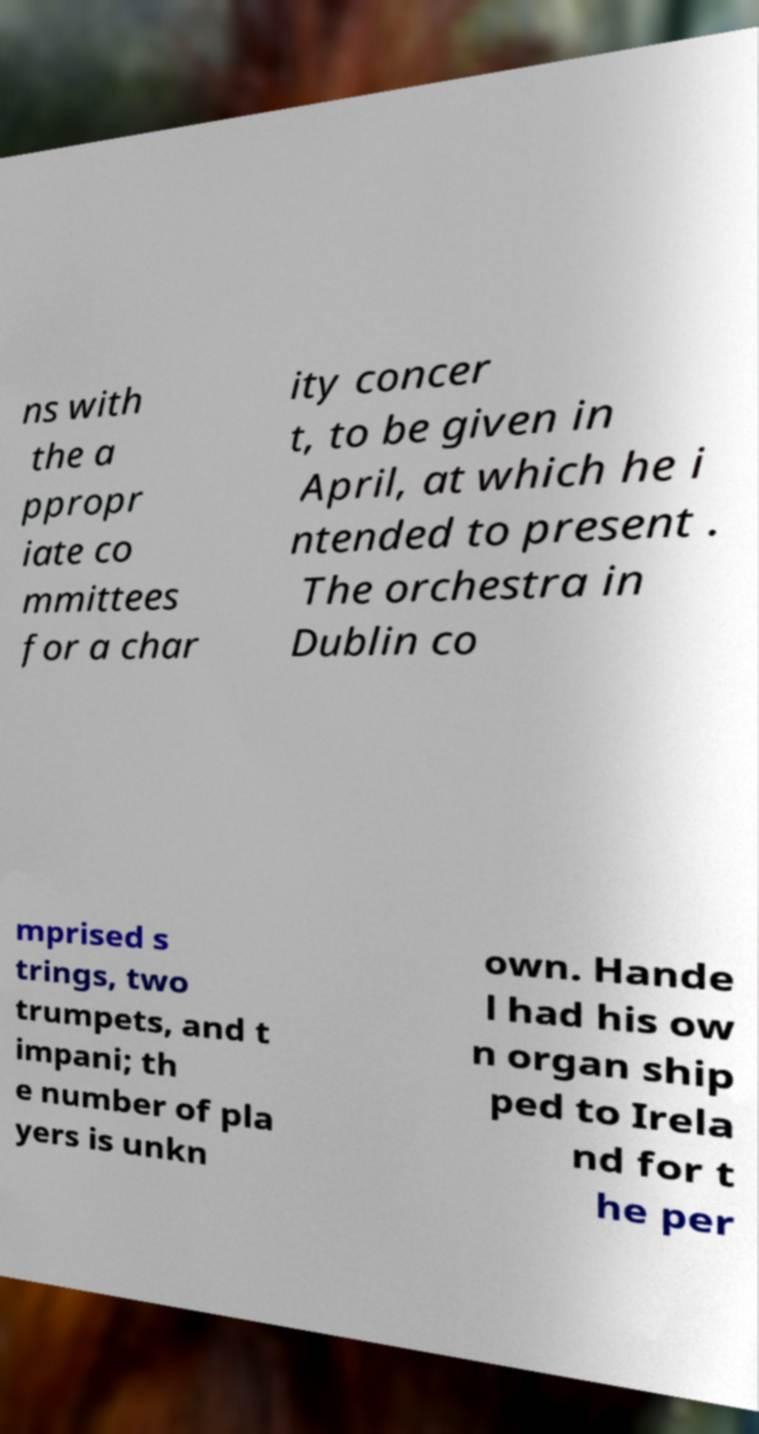Could you extract and type out the text from this image? ns with the a ppropr iate co mmittees for a char ity concer t, to be given in April, at which he i ntended to present . The orchestra in Dublin co mprised s trings, two trumpets, and t impani; th e number of pla yers is unkn own. Hande l had his ow n organ ship ped to Irela nd for t he per 